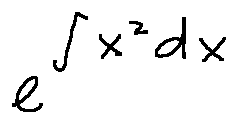<formula> <loc_0><loc_0><loc_500><loc_500>e ^ { \int x ^ { 2 } d x }</formula> 